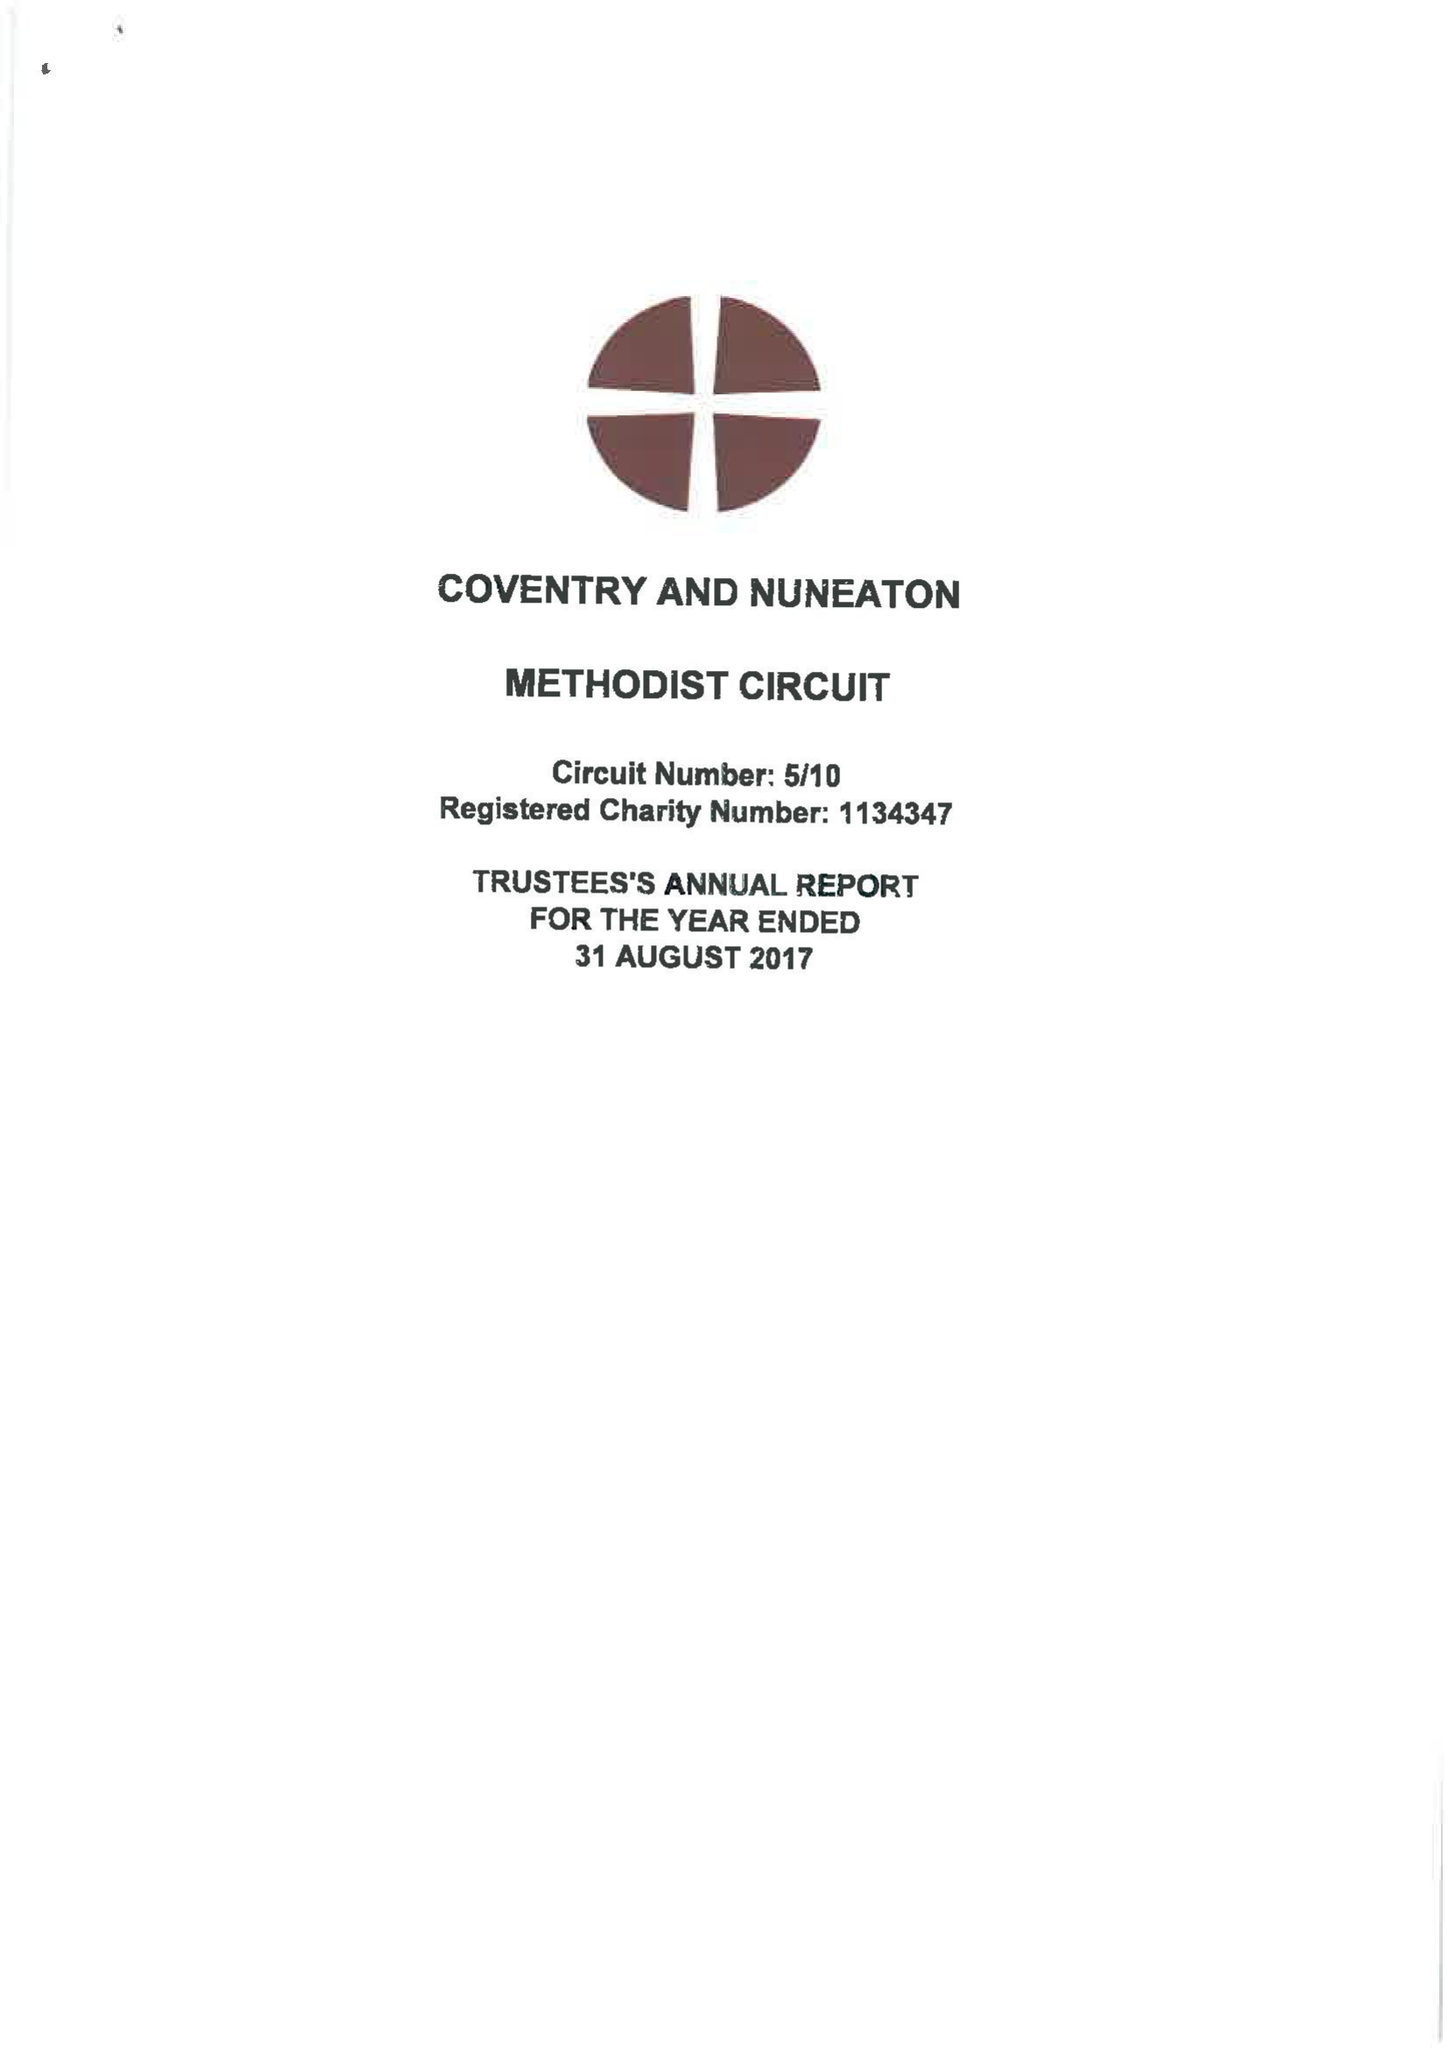What is the value for the charity_name?
Answer the question using a single word or phrase. Coventry and Nuneaton Methodist Circuit 